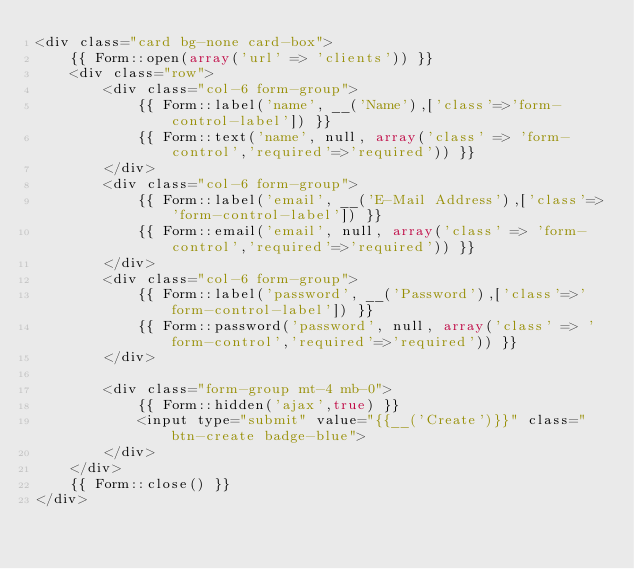Convert code to text. <code><loc_0><loc_0><loc_500><loc_500><_PHP_><div class="card bg-none card-box">
    {{ Form::open(array('url' => 'clients')) }}
    <div class="row">
        <div class="col-6 form-group">
            {{ Form::label('name', __('Name'),['class'=>'form-control-label']) }}
            {{ Form::text('name', null, array('class' => 'form-control','required'=>'required')) }}
        </div>
        <div class="col-6 form-group">
            {{ Form::label('email', __('E-Mail Address'),['class'=>'form-control-label']) }}
            {{ Form::email('email', null, array('class' => 'form-control','required'=>'required')) }}
        </div>
        <div class="col-6 form-group">
            {{ Form::label('password', __('Password'),['class'=>'form-control-label']) }}
            {{ Form::password('password', null, array('class' => 'form-control','required'=>'required')) }}
        </div>

        <div class="form-group mt-4 mb-0">
            {{ Form::hidden('ajax',true) }}
            <input type="submit" value="{{__('Create')}}" class="btn-create badge-blue">
        </div>
    </div>
    {{ Form::close() }}
</div>
</code> 